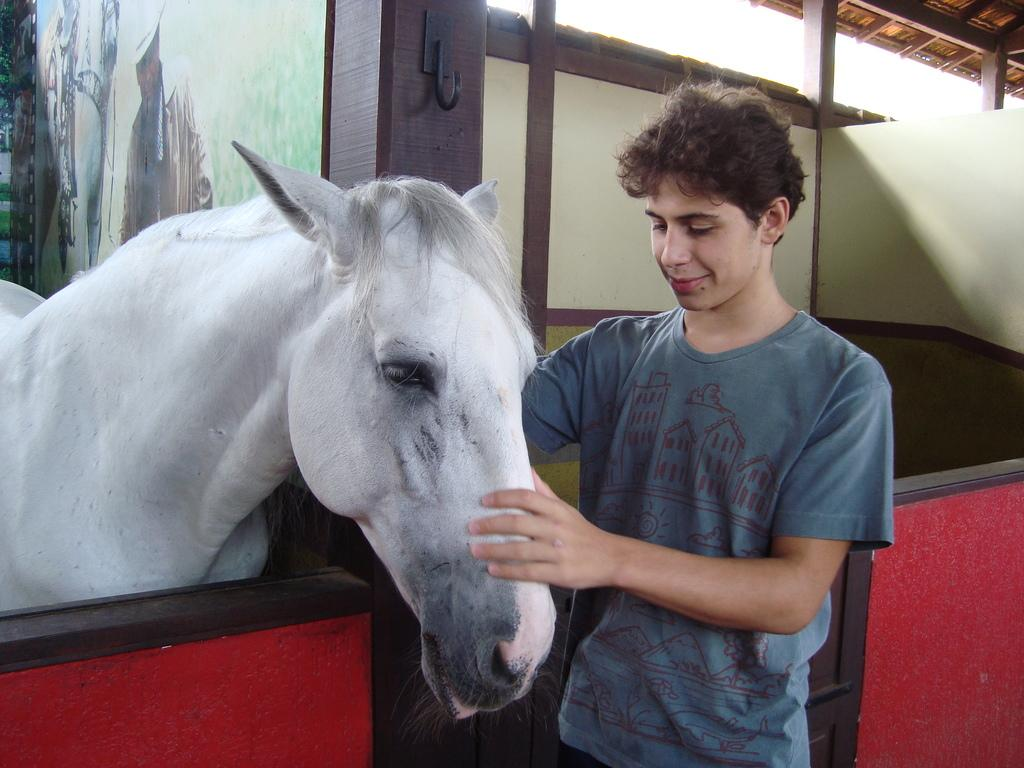What type of animal is in the image? There is a white horse in the image. Who else is present in the image? There is a man in the image. Can you describe the horse in the image? The horse is white. What type of brain can be seen in the image? There is no brain present in the image; it features a white horse and a man. Is there a woman in the image? No, there is no woman present in the image; it features a white horse and a man. 